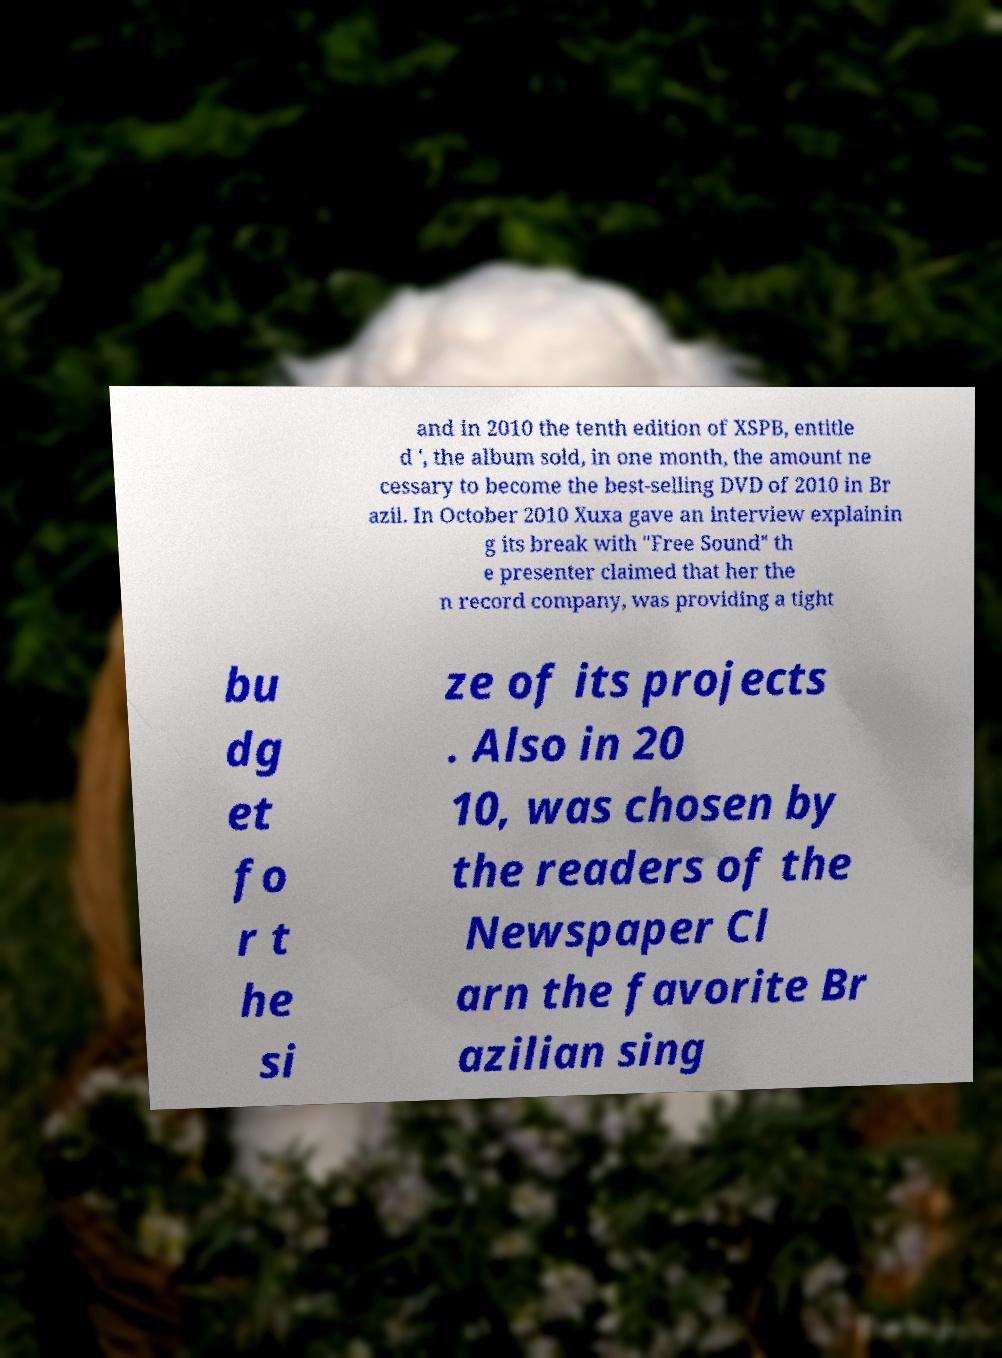For documentation purposes, I need the text within this image transcribed. Could you provide that? and in 2010 the tenth edition of XSPB, entitle d ', the album sold, in one month, the amount ne cessary to become the best-selling DVD of 2010 in Br azil. In October 2010 Xuxa gave an interview explainin g its break with "Free Sound" th e presenter claimed that her the n record company, was providing a tight bu dg et fo r t he si ze of its projects . Also in 20 10, was chosen by the readers of the Newspaper Cl arn the favorite Br azilian sing 